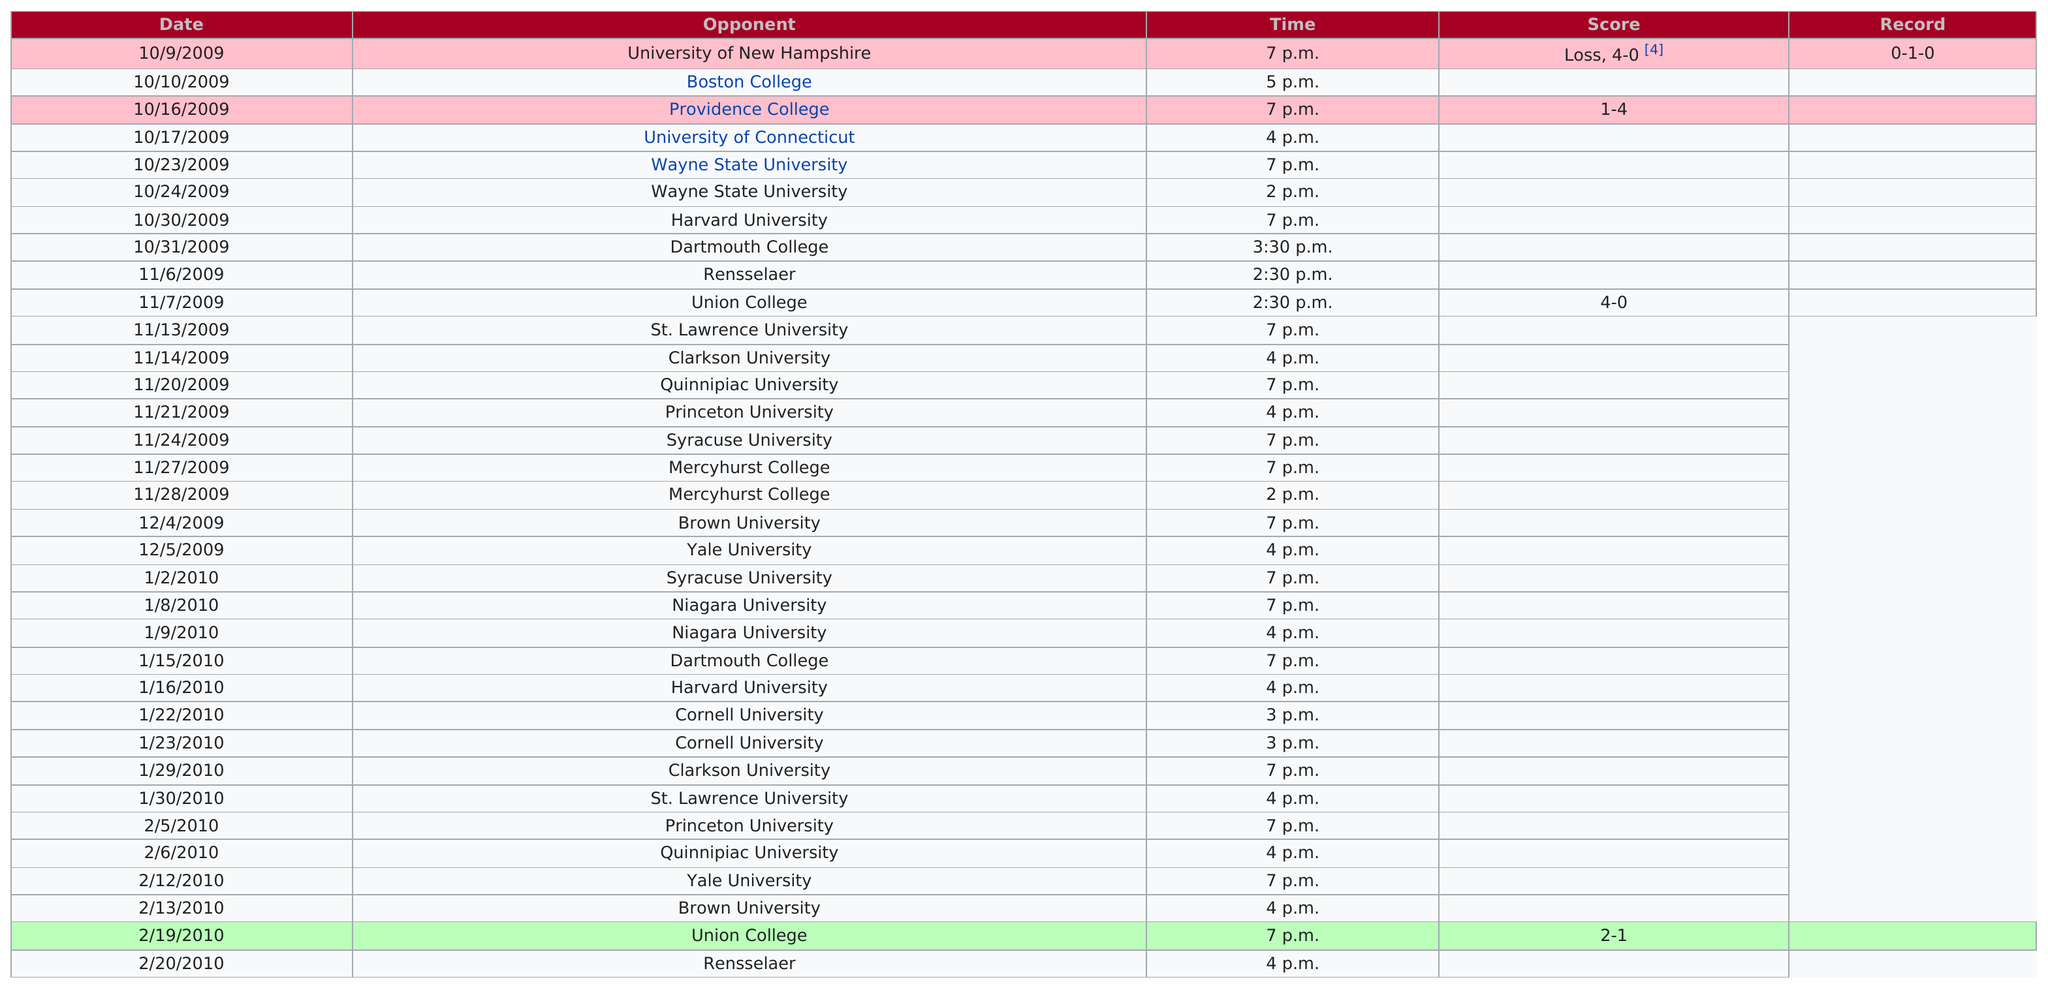Point out several critical features in this image. Rensselaer is the last opponent. The University of New Hampshire is scheduled to play first. On February 22nd, 2023, the following schools will be in session in order: Wayne State University, Mercyhurst College, Niagara University, and Cornell University. On February 20, 2010, the Raiders played their last game of the 2009-10 season. As of 4pm, there are 10 opponents participating in the game. 